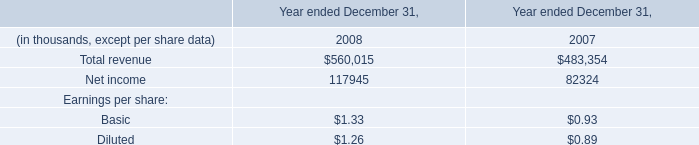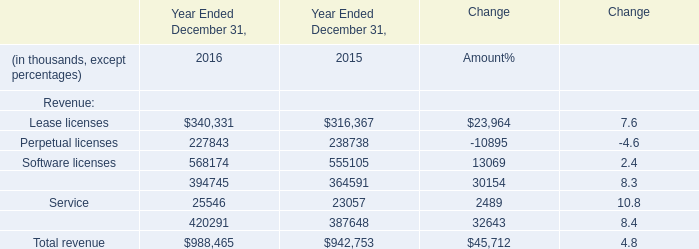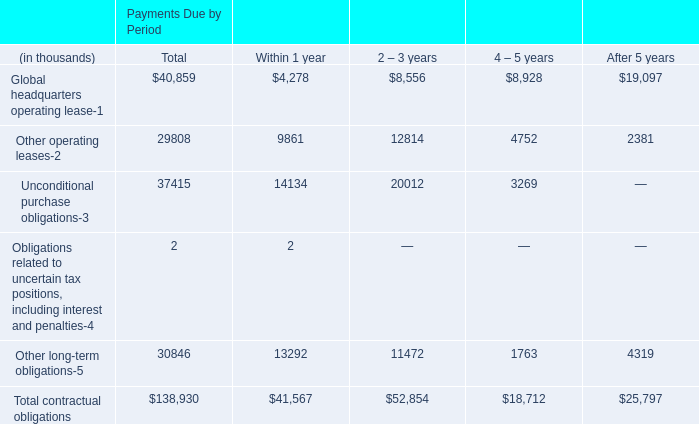What's the average of Net income of data 1 2007, and Lease licenses of Year Ended December 31, 2016 ? 
Computations: ((82324.0 + 340331.0) / 2)
Answer: 211327.5. 